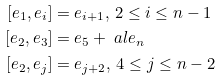Convert formula to latex. <formula><loc_0><loc_0><loc_500><loc_500>[ e _ { 1 } , e _ { i } ] & = e _ { i + 1 } , \, 2 \leq i \leq n - 1 \\ [ e _ { 2 } , e _ { 3 } ] & = e _ { 5 } + \ a l e _ { n } \\ [ e _ { 2 } , e _ { j } ] & = e _ { j + 2 } , \, 4 \leq j \leq n - 2 \\</formula> 